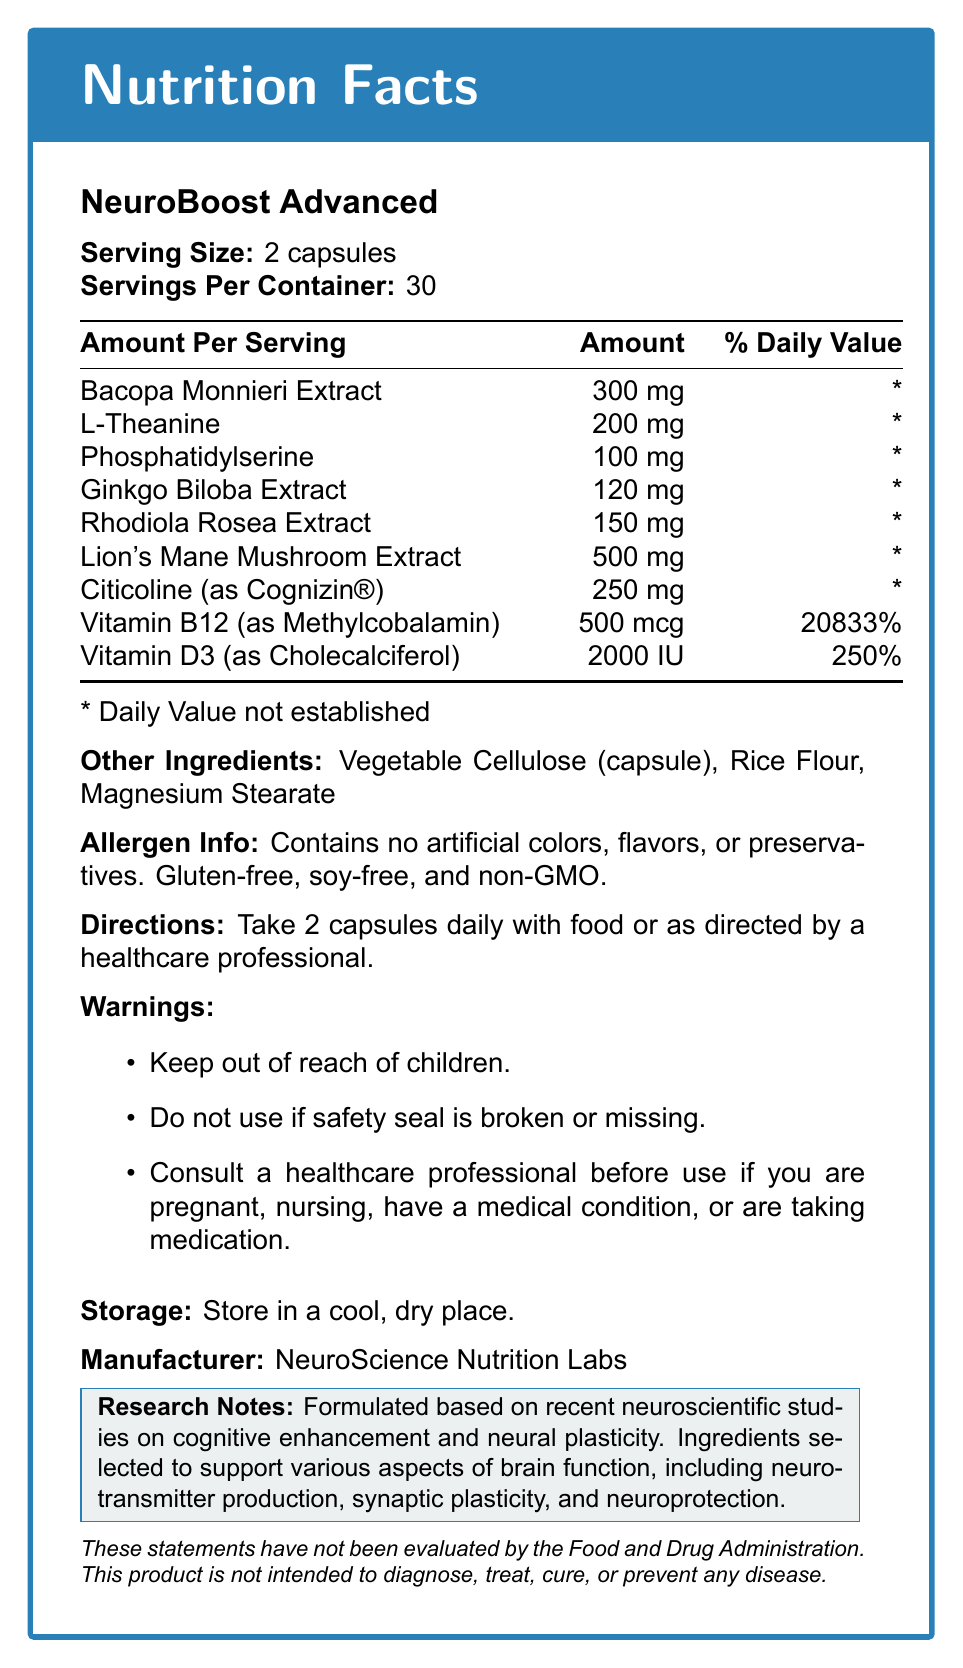what is the serving size for NeuroBoost Advanced? The serving size is explicitly mentioned as "Serving Size: 2 capsules".
Answer: 2 capsules how many servings are there per container? This information is provided in the document under "Servings Per Container: 30".
Answer: 30 which ingredient has the highest daily value percentage? Vitamin B12 has a daily value percentage of 20833%, the highest listed in the document.
Answer: Vitamin B12 (as Methylcobalamin) what is the main benefit of Citicoline (as Cognizin®)? The document states the benefit of Citicoline clearly: "Enhances brain energy and supports neurotransmitter production".
Answer: Enhances brain energy and supports neurotransmitter production what other ingredients are present in the NeuroBoost Advanced supplement? The document lists the other ingredients directly under "Other Ingredients".
Answer: Vegetable Cellulose (capsule), Rice Flour, Magnesium Stearate which of the following ingredients is NOT a benefit of Bacopa Monnieri Extract? A. Supports memory and cognitive function B. Enhances blood flow to the brain C. Supports nerve growth factor production Bacopa Monnieri Extract is listed to support memory and cognitive function, but not nerve growth factor production.
Answer: C The NeuroBoost Advanced supplement is suitable for which of the following? A. People with gluten intolerance B. People who are allergic to soy C. People who prefer non-GMO products D. All of the above The allergen info section states: "Contains no artificial colors, flavors, or preservatives. Gluten-free, soy-free, and non-GMO."
Answer: D is the supplement safe to use if the safety seal is broken? The warnings section specifically mentions not to use the supplement if the safety seal is broken or missing.
Answer: No summarize the main idea of the document. The document provides a comprehensive overview of the NeuroBoost Advanced supplement, including its components, benefits, usage instructions, and additional notes on research and safety.
Answer: NeuroBoost Advanced is a cognitive enhancement supplement that includes a detailed breakdown of nootropic ingredients, their respective benefits, and instructions for use. The document also lists other ingredients, allergen info, and warnings. The supplement is formulated based on recent neuroscientific studies to support various aspects of brain function. what is the benefit of Lion's Mane Mushroom Extract? The benefit of Lion's Mane Mushroom Extract is listed as "Supports nerve growth factor production".
Answer: Supports nerve growth factor production is there enough information to determine the price of the NeuroBoost Advanced supplement? The document does not provide any information regarding the price of the supplement.
Answer: Cannot be determined who manufactures NeuroBoost Advanced? The document mentions "Manufacturer: NeuroScience Nutrition Labs" under the storage information.
Answer: NeuroScience Nutrition Labs 